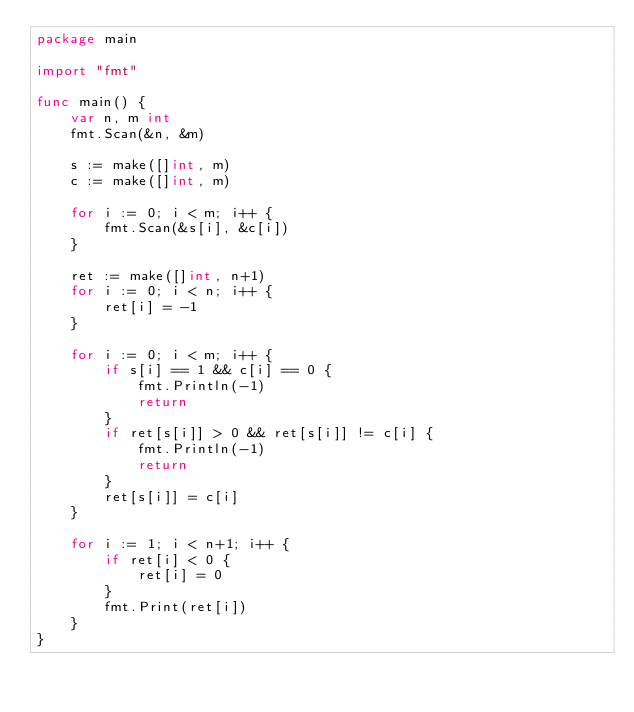<code> <loc_0><loc_0><loc_500><loc_500><_Go_>package main

import "fmt"

func main() {
	var n, m int
	fmt.Scan(&n, &m)

	s := make([]int, m)
	c := make([]int, m)

	for i := 0; i < m; i++ {
		fmt.Scan(&s[i], &c[i])
	}

	ret := make([]int, n+1)
	for i := 0; i < n; i++ {
		ret[i] = -1
	}

	for i := 0; i < m; i++ {
		if s[i] == 1 && c[i] == 0 {
			fmt.Println(-1)
			return
		}
		if ret[s[i]] > 0 && ret[s[i]] != c[i] {
			fmt.Println(-1)
			return
		}
		ret[s[i]] = c[i]
	}

	for i := 1; i < n+1; i++ {
		if ret[i] < 0 {
			ret[i] = 0
		}
		fmt.Print(ret[i])
	}
}
</code> 